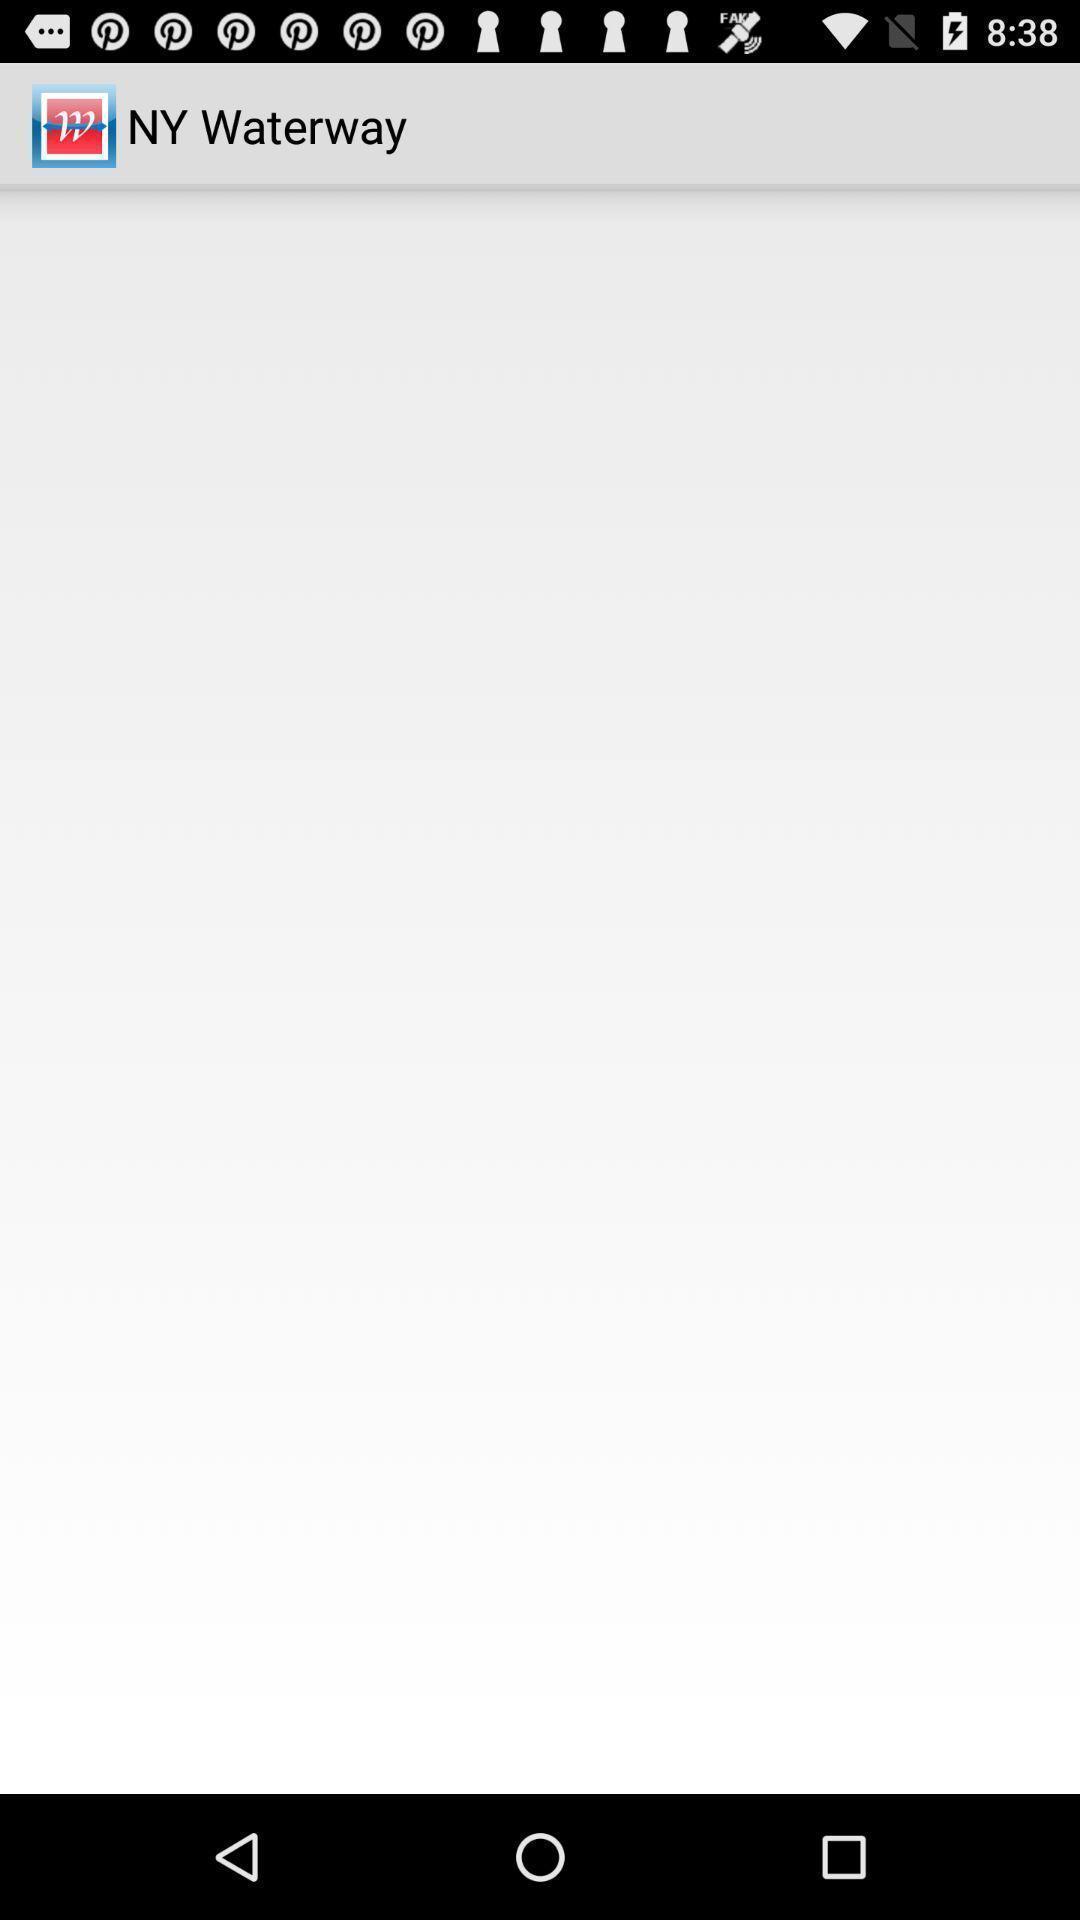Describe the visual elements of this screenshot. Screen displaying blank page. 